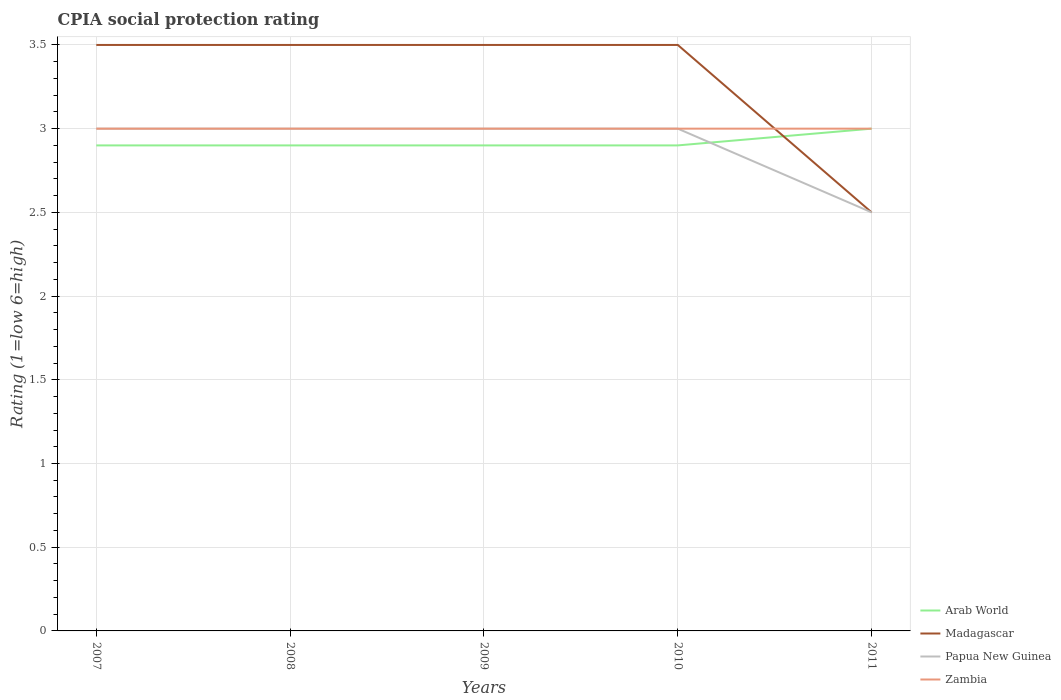Across all years, what is the maximum CPIA rating in Arab World?
Your answer should be compact. 2.9. What is the total CPIA rating in Madagascar in the graph?
Your answer should be very brief. 0. What is the difference between the highest and the second highest CPIA rating in Arab World?
Give a very brief answer. 0.1. Is the CPIA rating in Madagascar strictly greater than the CPIA rating in Zambia over the years?
Your response must be concise. No. How many lines are there?
Offer a very short reply. 4. Does the graph contain grids?
Offer a very short reply. Yes. Where does the legend appear in the graph?
Your answer should be compact. Bottom right. How many legend labels are there?
Make the answer very short. 4. How are the legend labels stacked?
Provide a succinct answer. Vertical. What is the title of the graph?
Offer a terse response. CPIA social protection rating. What is the label or title of the X-axis?
Make the answer very short. Years. What is the Rating (1=low 6=high) in Arab World in 2007?
Your response must be concise. 2.9. What is the Rating (1=low 6=high) in Madagascar in 2007?
Ensure brevity in your answer.  3.5. What is the Rating (1=low 6=high) in Papua New Guinea in 2007?
Your answer should be very brief. 3. What is the Rating (1=low 6=high) of Zambia in 2007?
Your answer should be compact. 3. What is the Rating (1=low 6=high) of Papua New Guinea in 2008?
Provide a short and direct response. 3. What is the Rating (1=low 6=high) in Papua New Guinea in 2009?
Offer a terse response. 3. What is the Rating (1=low 6=high) in Zambia in 2009?
Ensure brevity in your answer.  3. What is the Rating (1=low 6=high) of Arab World in 2010?
Provide a short and direct response. 2.9. What is the Rating (1=low 6=high) of Papua New Guinea in 2010?
Your answer should be compact. 3. What is the Rating (1=low 6=high) in Arab World in 2011?
Offer a very short reply. 3. What is the Rating (1=low 6=high) in Papua New Guinea in 2011?
Your answer should be compact. 2.5. What is the Rating (1=low 6=high) in Zambia in 2011?
Provide a short and direct response. 3. Across all years, what is the maximum Rating (1=low 6=high) in Madagascar?
Give a very brief answer. 3.5. Across all years, what is the maximum Rating (1=low 6=high) of Papua New Guinea?
Your answer should be very brief. 3. Across all years, what is the minimum Rating (1=low 6=high) in Arab World?
Make the answer very short. 2.9. What is the total Rating (1=low 6=high) of Madagascar in the graph?
Keep it short and to the point. 16.5. What is the total Rating (1=low 6=high) of Papua New Guinea in the graph?
Make the answer very short. 14.5. What is the total Rating (1=low 6=high) of Zambia in the graph?
Keep it short and to the point. 15. What is the difference between the Rating (1=low 6=high) of Arab World in 2007 and that in 2008?
Provide a short and direct response. 0. What is the difference between the Rating (1=low 6=high) of Arab World in 2007 and that in 2009?
Keep it short and to the point. 0. What is the difference between the Rating (1=low 6=high) in Papua New Guinea in 2007 and that in 2009?
Your answer should be compact. 0. What is the difference between the Rating (1=low 6=high) in Madagascar in 2007 and that in 2010?
Your answer should be compact. 0. What is the difference between the Rating (1=low 6=high) in Arab World in 2007 and that in 2011?
Make the answer very short. -0.1. What is the difference between the Rating (1=low 6=high) in Papua New Guinea in 2007 and that in 2011?
Keep it short and to the point. 0.5. What is the difference between the Rating (1=low 6=high) in Arab World in 2008 and that in 2009?
Offer a terse response. 0. What is the difference between the Rating (1=low 6=high) of Madagascar in 2008 and that in 2009?
Your response must be concise. 0. What is the difference between the Rating (1=low 6=high) of Zambia in 2008 and that in 2010?
Keep it short and to the point. 0. What is the difference between the Rating (1=low 6=high) in Arab World in 2009 and that in 2010?
Your answer should be very brief. 0. What is the difference between the Rating (1=low 6=high) of Papua New Guinea in 2009 and that in 2010?
Your answer should be compact. 0. What is the difference between the Rating (1=low 6=high) of Zambia in 2009 and that in 2010?
Provide a succinct answer. 0. What is the difference between the Rating (1=low 6=high) in Madagascar in 2009 and that in 2011?
Give a very brief answer. 1. What is the difference between the Rating (1=low 6=high) in Papua New Guinea in 2009 and that in 2011?
Offer a terse response. 0.5. What is the difference between the Rating (1=low 6=high) in Zambia in 2010 and that in 2011?
Your response must be concise. 0. What is the difference between the Rating (1=low 6=high) of Arab World in 2007 and the Rating (1=low 6=high) of Madagascar in 2008?
Your answer should be very brief. -0.6. What is the difference between the Rating (1=low 6=high) of Arab World in 2007 and the Rating (1=low 6=high) of Zambia in 2008?
Your answer should be very brief. -0.1. What is the difference between the Rating (1=low 6=high) of Madagascar in 2007 and the Rating (1=low 6=high) of Papua New Guinea in 2008?
Ensure brevity in your answer.  0.5. What is the difference between the Rating (1=low 6=high) of Papua New Guinea in 2007 and the Rating (1=low 6=high) of Zambia in 2008?
Ensure brevity in your answer.  0. What is the difference between the Rating (1=low 6=high) in Papua New Guinea in 2007 and the Rating (1=low 6=high) in Zambia in 2009?
Make the answer very short. 0. What is the difference between the Rating (1=low 6=high) of Arab World in 2007 and the Rating (1=low 6=high) of Madagascar in 2010?
Provide a succinct answer. -0.6. What is the difference between the Rating (1=low 6=high) of Arab World in 2007 and the Rating (1=low 6=high) of Zambia in 2010?
Your response must be concise. -0.1. What is the difference between the Rating (1=low 6=high) in Madagascar in 2007 and the Rating (1=low 6=high) in Zambia in 2010?
Make the answer very short. 0.5. What is the difference between the Rating (1=low 6=high) of Arab World in 2007 and the Rating (1=low 6=high) of Zambia in 2011?
Provide a short and direct response. -0.1. What is the difference between the Rating (1=low 6=high) of Madagascar in 2007 and the Rating (1=low 6=high) of Papua New Guinea in 2011?
Offer a terse response. 1. What is the difference between the Rating (1=low 6=high) in Madagascar in 2007 and the Rating (1=low 6=high) in Zambia in 2011?
Ensure brevity in your answer.  0.5. What is the difference between the Rating (1=low 6=high) in Papua New Guinea in 2007 and the Rating (1=low 6=high) in Zambia in 2011?
Provide a succinct answer. 0. What is the difference between the Rating (1=low 6=high) in Arab World in 2008 and the Rating (1=low 6=high) in Papua New Guinea in 2009?
Provide a succinct answer. -0.1. What is the difference between the Rating (1=low 6=high) of Arab World in 2008 and the Rating (1=low 6=high) of Madagascar in 2010?
Offer a very short reply. -0.6. What is the difference between the Rating (1=low 6=high) in Arab World in 2008 and the Rating (1=low 6=high) in Zambia in 2010?
Provide a short and direct response. -0.1. What is the difference between the Rating (1=low 6=high) in Madagascar in 2008 and the Rating (1=low 6=high) in Zambia in 2010?
Keep it short and to the point. 0.5. What is the difference between the Rating (1=low 6=high) of Arab World in 2008 and the Rating (1=low 6=high) of Madagascar in 2011?
Offer a very short reply. 0.4. What is the difference between the Rating (1=low 6=high) of Arab World in 2008 and the Rating (1=low 6=high) of Zambia in 2011?
Offer a very short reply. -0.1. What is the difference between the Rating (1=low 6=high) in Madagascar in 2008 and the Rating (1=low 6=high) in Zambia in 2011?
Offer a very short reply. 0.5. What is the difference between the Rating (1=low 6=high) of Papua New Guinea in 2008 and the Rating (1=low 6=high) of Zambia in 2011?
Offer a very short reply. 0. What is the difference between the Rating (1=low 6=high) of Arab World in 2009 and the Rating (1=low 6=high) of Papua New Guinea in 2010?
Offer a terse response. -0.1. What is the difference between the Rating (1=low 6=high) of Arab World in 2009 and the Rating (1=low 6=high) of Zambia in 2010?
Offer a terse response. -0.1. What is the difference between the Rating (1=low 6=high) in Madagascar in 2009 and the Rating (1=low 6=high) in Papua New Guinea in 2010?
Offer a very short reply. 0.5. What is the difference between the Rating (1=low 6=high) in Arab World in 2009 and the Rating (1=low 6=high) in Madagascar in 2011?
Your answer should be compact. 0.4. What is the difference between the Rating (1=low 6=high) of Arab World in 2009 and the Rating (1=low 6=high) of Zambia in 2011?
Offer a very short reply. -0.1. What is the difference between the Rating (1=low 6=high) in Madagascar in 2009 and the Rating (1=low 6=high) in Papua New Guinea in 2011?
Make the answer very short. 1. What is the difference between the Rating (1=low 6=high) of Madagascar in 2009 and the Rating (1=low 6=high) of Zambia in 2011?
Keep it short and to the point. 0.5. What is the difference between the Rating (1=low 6=high) of Papua New Guinea in 2009 and the Rating (1=low 6=high) of Zambia in 2011?
Provide a succinct answer. 0. What is the difference between the Rating (1=low 6=high) of Arab World in 2010 and the Rating (1=low 6=high) of Zambia in 2011?
Keep it short and to the point. -0.1. What is the difference between the Rating (1=low 6=high) in Madagascar in 2010 and the Rating (1=low 6=high) in Papua New Guinea in 2011?
Provide a short and direct response. 1. What is the difference between the Rating (1=low 6=high) of Madagascar in 2010 and the Rating (1=low 6=high) of Zambia in 2011?
Ensure brevity in your answer.  0.5. What is the average Rating (1=low 6=high) of Arab World per year?
Your response must be concise. 2.92. What is the average Rating (1=low 6=high) of Papua New Guinea per year?
Give a very brief answer. 2.9. What is the average Rating (1=low 6=high) in Zambia per year?
Give a very brief answer. 3. In the year 2007, what is the difference between the Rating (1=low 6=high) in Arab World and Rating (1=low 6=high) in Papua New Guinea?
Ensure brevity in your answer.  -0.1. In the year 2007, what is the difference between the Rating (1=low 6=high) in Arab World and Rating (1=low 6=high) in Zambia?
Your answer should be compact. -0.1. In the year 2007, what is the difference between the Rating (1=low 6=high) in Madagascar and Rating (1=low 6=high) in Papua New Guinea?
Your answer should be compact. 0.5. In the year 2007, what is the difference between the Rating (1=low 6=high) in Papua New Guinea and Rating (1=low 6=high) in Zambia?
Offer a very short reply. 0. In the year 2008, what is the difference between the Rating (1=low 6=high) of Arab World and Rating (1=low 6=high) of Papua New Guinea?
Offer a very short reply. -0.1. In the year 2008, what is the difference between the Rating (1=low 6=high) of Papua New Guinea and Rating (1=low 6=high) of Zambia?
Offer a terse response. 0. In the year 2009, what is the difference between the Rating (1=low 6=high) of Arab World and Rating (1=low 6=high) of Madagascar?
Ensure brevity in your answer.  -0.6. In the year 2009, what is the difference between the Rating (1=low 6=high) of Madagascar and Rating (1=low 6=high) of Papua New Guinea?
Provide a succinct answer. 0.5. In the year 2010, what is the difference between the Rating (1=low 6=high) in Arab World and Rating (1=low 6=high) in Madagascar?
Keep it short and to the point. -0.6. In the year 2010, what is the difference between the Rating (1=low 6=high) in Arab World and Rating (1=low 6=high) in Papua New Guinea?
Your answer should be very brief. -0.1. In the year 2010, what is the difference between the Rating (1=low 6=high) in Arab World and Rating (1=low 6=high) in Zambia?
Ensure brevity in your answer.  -0.1. In the year 2010, what is the difference between the Rating (1=low 6=high) in Madagascar and Rating (1=low 6=high) in Zambia?
Provide a succinct answer. 0.5. In the year 2010, what is the difference between the Rating (1=low 6=high) in Papua New Guinea and Rating (1=low 6=high) in Zambia?
Make the answer very short. 0. In the year 2011, what is the difference between the Rating (1=low 6=high) of Arab World and Rating (1=low 6=high) of Madagascar?
Give a very brief answer. 0.5. In the year 2011, what is the difference between the Rating (1=low 6=high) in Arab World and Rating (1=low 6=high) in Papua New Guinea?
Give a very brief answer. 0.5. In the year 2011, what is the difference between the Rating (1=low 6=high) of Madagascar and Rating (1=low 6=high) of Papua New Guinea?
Your answer should be compact. 0. In the year 2011, what is the difference between the Rating (1=low 6=high) of Madagascar and Rating (1=low 6=high) of Zambia?
Give a very brief answer. -0.5. In the year 2011, what is the difference between the Rating (1=low 6=high) in Papua New Guinea and Rating (1=low 6=high) in Zambia?
Your answer should be compact. -0.5. What is the ratio of the Rating (1=low 6=high) of Papua New Guinea in 2007 to that in 2009?
Provide a short and direct response. 1. What is the ratio of the Rating (1=low 6=high) of Zambia in 2007 to that in 2010?
Offer a terse response. 1. What is the ratio of the Rating (1=low 6=high) in Arab World in 2007 to that in 2011?
Make the answer very short. 0.97. What is the ratio of the Rating (1=low 6=high) of Madagascar in 2007 to that in 2011?
Provide a short and direct response. 1.4. What is the ratio of the Rating (1=low 6=high) of Papua New Guinea in 2007 to that in 2011?
Your response must be concise. 1.2. What is the ratio of the Rating (1=low 6=high) in Zambia in 2007 to that in 2011?
Ensure brevity in your answer.  1. What is the ratio of the Rating (1=low 6=high) of Arab World in 2008 to that in 2009?
Keep it short and to the point. 1. What is the ratio of the Rating (1=low 6=high) of Madagascar in 2008 to that in 2009?
Keep it short and to the point. 1. What is the ratio of the Rating (1=low 6=high) in Papua New Guinea in 2008 to that in 2009?
Make the answer very short. 1. What is the ratio of the Rating (1=low 6=high) in Arab World in 2008 to that in 2010?
Keep it short and to the point. 1. What is the ratio of the Rating (1=low 6=high) in Arab World in 2008 to that in 2011?
Your answer should be very brief. 0.97. What is the ratio of the Rating (1=low 6=high) of Madagascar in 2009 to that in 2010?
Provide a succinct answer. 1. What is the ratio of the Rating (1=low 6=high) in Papua New Guinea in 2009 to that in 2010?
Keep it short and to the point. 1. What is the ratio of the Rating (1=low 6=high) of Zambia in 2009 to that in 2010?
Keep it short and to the point. 1. What is the ratio of the Rating (1=low 6=high) in Arab World in 2009 to that in 2011?
Ensure brevity in your answer.  0.97. What is the ratio of the Rating (1=low 6=high) in Madagascar in 2009 to that in 2011?
Your answer should be compact. 1.4. What is the ratio of the Rating (1=low 6=high) of Arab World in 2010 to that in 2011?
Provide a succinct answer. 0.97. What is the ratio of the Rating (1=low 6=high) of Papua New Guinea in 2010 to that in 2011?
Keep it short and to the point. 1.2. What is the ratio of the Rating (1=low 6=high) in Zambia in 2010 to that in 2011?
Offer a terse response. 1. What is the difference between the highest and the second highest Rating (1=low 6=high) in Papua New Guinea?
Offer a very short reply. 0. What is the difference between the highest and the second highest Rating (1=low 6=high) of Zambia?
Give a very brief answer. 0. What is the difference between the highest and the lowest Rating (1=low 6=high) of Papua New Guinea?
Make the answer very short. 0.5. 